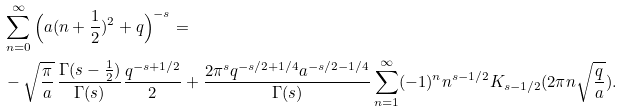Convert formula to latex. <formula><loc_0><loc_0><loc_500><loc_500>& \sum _ { n = 0 } ^ { \infty } \Big { ( } a ( n + \frac { 1 } { 2 } ) ^ { 2 } + q \Big { ) } ^ { - s } = \\ & - \sqrt { \frac { \pi } { a } } { \, } \frac { \Gamma ( s - \frac { 1 } { 2 } ) } { \Gamma ( s ) } \frac { q ^ { - s + 1 / 2 } } { 2 } + \frac { 2 \pi ^ { s } q ^ { - s / 2 + 1 / 4 } a ^ { - s / 2 - 1 / 4 } } { \Gamma ( s ) } \sum _ { n = 1 } ^ { \infty } ( - 1 ) ^ { n } n ^ { s - 1 / 2 } K _ { s - 1 / 2 } ( 2 \pi n \sqrt { \frac { q } { a } } ) .</formula> 